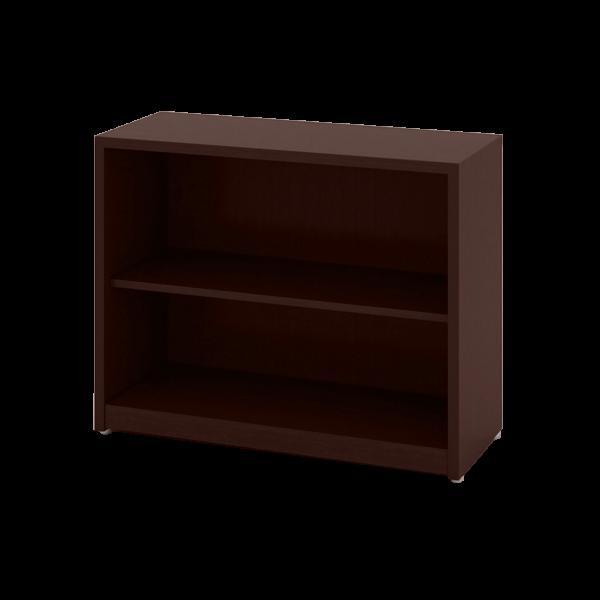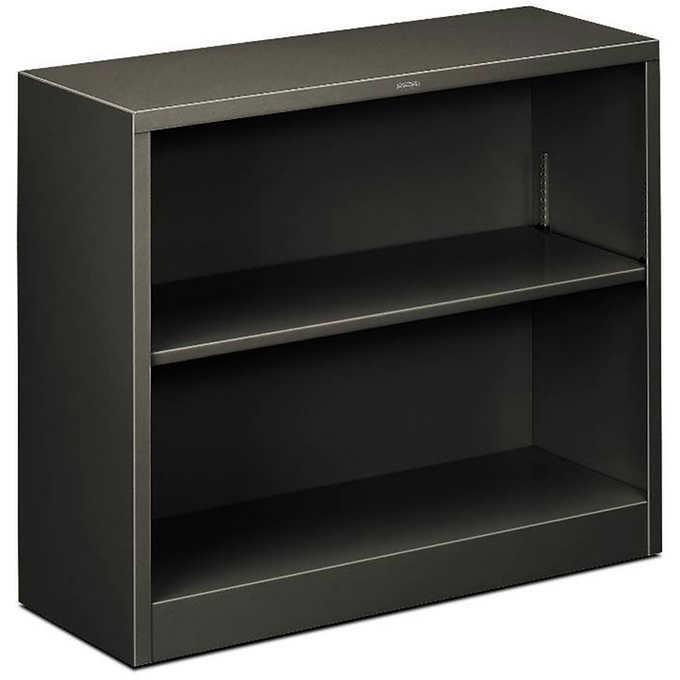The first image is the image on the left, the second image is the image on the right. Analyze the images presented: Is the assertion "The left and right image contains the same number shelves facing opposite ways." valid? Answer yes or no. Yes. The first image is the image on the left, the second image is the image on the right. Examine the images to the left and right. Is the description "Two bookcases are wider than they are tall and have two inner shelves, but only one sits flush on the floor." accurate? Answer yes or no. Yes. 